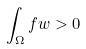<formula> <loc_0><loc_0><loc_500><loc_500>\int _ { \Omega } f w > 0</formula> 